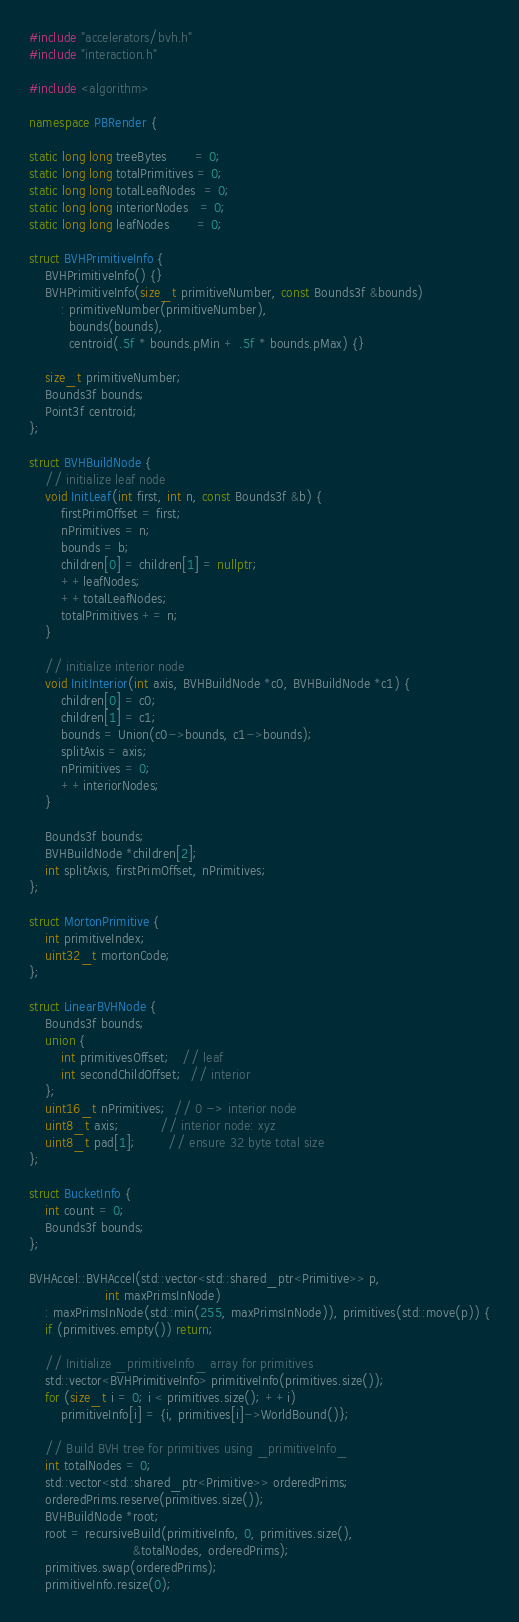Convert code to text. <code><loc_0><loc_0><loc_500><loc_500><_C++_>#include "accelerators/bvh.h"
#include "interaction.h"

#include <algorithm>

namespace PBRender {

static long long treeBytes       = 0;
static long long totalPrimitives = 0;
static long long totalLeafNodes  = 0;
static long long interiorNodes   = 0;
static long long leafNodes       = 0;

struct BVHPrimitiveInfo {
    BVHPrimitiveInfo() {}
    BVHPrimitiveInfo(size_t primitiveNumber, const Bounds3f &bounds)
        : primitiveNumber(primitiveNumber),
          bounds(bounds),
          centroid(.5f * bounds.pMin + .5f * bounds.pMax) {}
    
    size_t primitiveNumber;
    Bounds3f bounds;
    Point3f centroid;
};

struct BVHBuildNode {
    // initialize leaf node
    void InitLeaf(int first, int n, const Bounds3f &b) {
        firstPrimOffset = first;
        nPrimitives = n;
        bounds = b;
        children[0] = children[1] = nullptr;
        ++leafNodes;
        ++totalLeafNodes;
        totalPrimitives += n;
    }

    // initialize interior node
    void InitInterior(int axis, BVHBuildNode *c0, BVHBuildNode *c1) {
        children[0] = c0;
        children[1] = c1;
        bounds = Union(c0->bounds, c1->bounds);
        splitAxis = axis;
        nPrimitives = 0;
        ++interiorNodes;
    }

    Bounds3f bounds;
    BVHBuildNode *children[2];
    int splitAxis, firstPrimOffset, nPrimitives;
};

struct MortonPrimitive {
    int primitiveIndex;
    uint32_t mortonCode;
};

struct LinearBVHNode {
    Bounds3f bounds;
    union {
        int primitivesOffset;   // leaf
        int secondChildOffset;  // interior
    };
    uint16_t nPrimitives;  // 0 -> interior node
    uint8_t axis;          // interior node: xyz
    uint8_t pad[1];        // ensure 32 byte total size
};

struct BucketInfo {
    int count = 0;
    Bounds3f bounds;
};

BVHAccel::BVHAccel(std::vector<std::shared_ptr<Primitive>> p,
                   int maxPrimsInNode)
    : maxPrimsInNode(std::min(255, maxPrimsInNode)), primitives(std::move(p)) {
    if (primitives.empty()) return;

    // Initialize _primitiveInfo_ array for primitives
    std::vector<BVHPrimitiveInfo> primitiveInfo(primitives.size());
    for (size_t i = 0; i < primitives.size(); ++i)
        primitiveInfo[i] = {i, primitives[i]->WorldBound()};
    
    // Build BVH tree for primitives using _primitiveInfo_
    int totalNodes = 0;
    std::vector<std::shared_ptr<Primitive>> orderedPrims;
    orderedPrims.reserve(primitives.size());
    BVHBuildNode *root;
    root = recursiveBuild(primitiveInfo, 0, primitives.size(),
                          &totalNodes, orderedPrims);
    primitives.swap(orderedPrims);
    primitiveInfo.resize(0);
</code> 